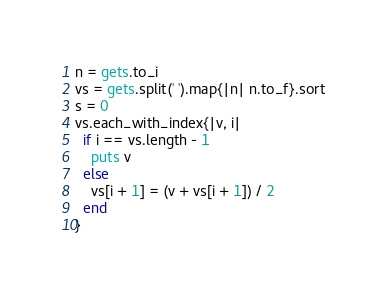Convert code to text. <code><loc_0><loc_0><loc_500><loc_500><_Ruby_>n = gets.to_i
vs = gets.split(' ').map{|n| n.to_f}.sort
s = 0
vs.each_with_index{|v, i|
  if i == vs.length - 1
    puts v
  else
    vs[i + 1] = (v + vs[i + 1]) / 2
  end
}</code> 